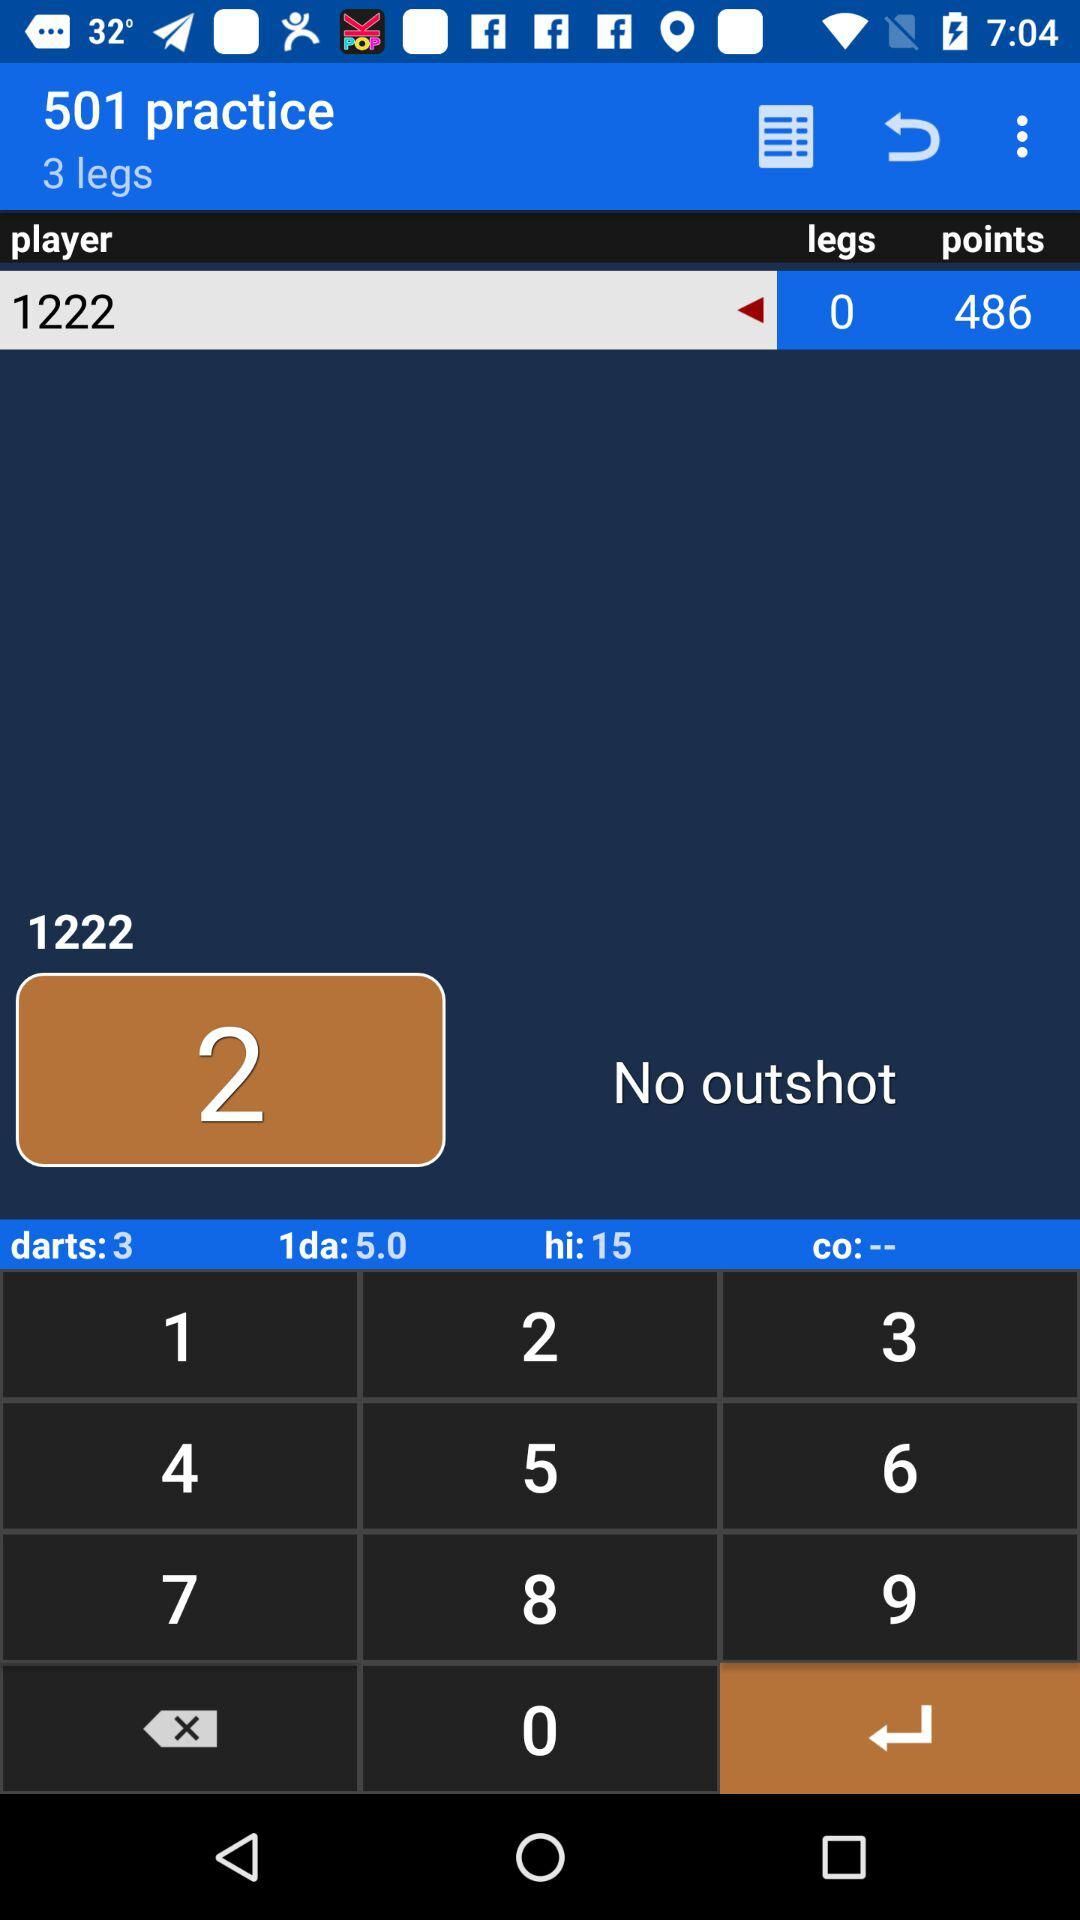What is the total count of darts? The total count is 3. 